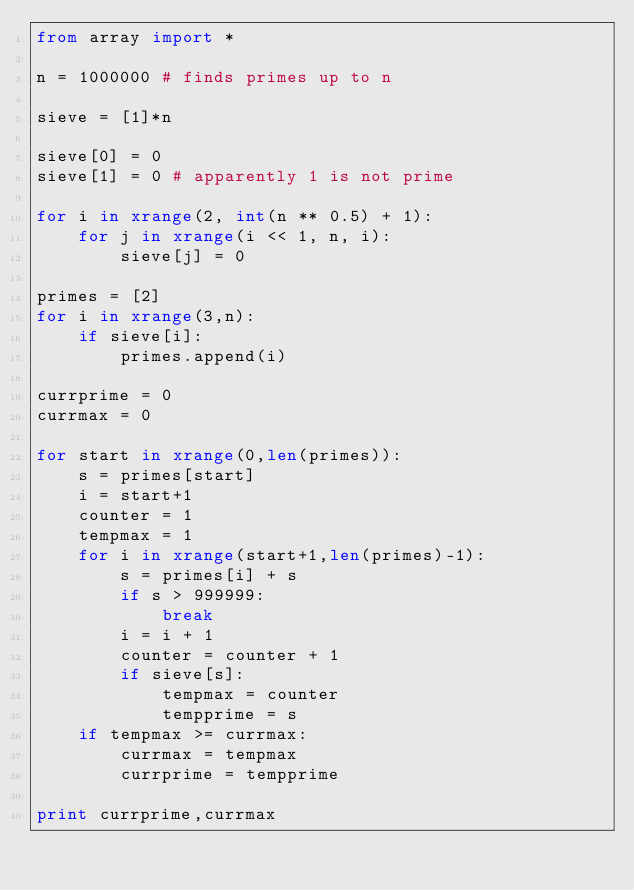Convert code to text. <code><loc_0><loc_0><loc_500><loc_500><_Python_>from array import *

n = 1000000 # finds primes up to n

sieve = [1]*n

sieve[0] = 0
sieve[1] = 0 # apparently 1 is not prime

for i in xrange(2, int(n ** 0.5) + 1):
    for j in xrange(i << 1, n, i):
        sieve[j] = 0
        
primes = [2]
for i in xrange(3,n):
    if sieve[i]:
        primes.append(i)

currprime = 0
currmax = 0

for start in xrange(0,len(primes)):
    s = primes[start]
    i = start+1
    counter = 1
    tempmax = 1
    for i in xrange(start+1,len(primes)-1):
        s = primes[i] + s
        if s > 999999:
            break
        i = i + 1
        counter = counter + 1
        if sieve[s]:
            tempmax = counter
            tempprime = s
    if tempmax >= currmax:
        currmax = tempmax
        currprime = tempprime
        
print currprime,currmax
</code> 